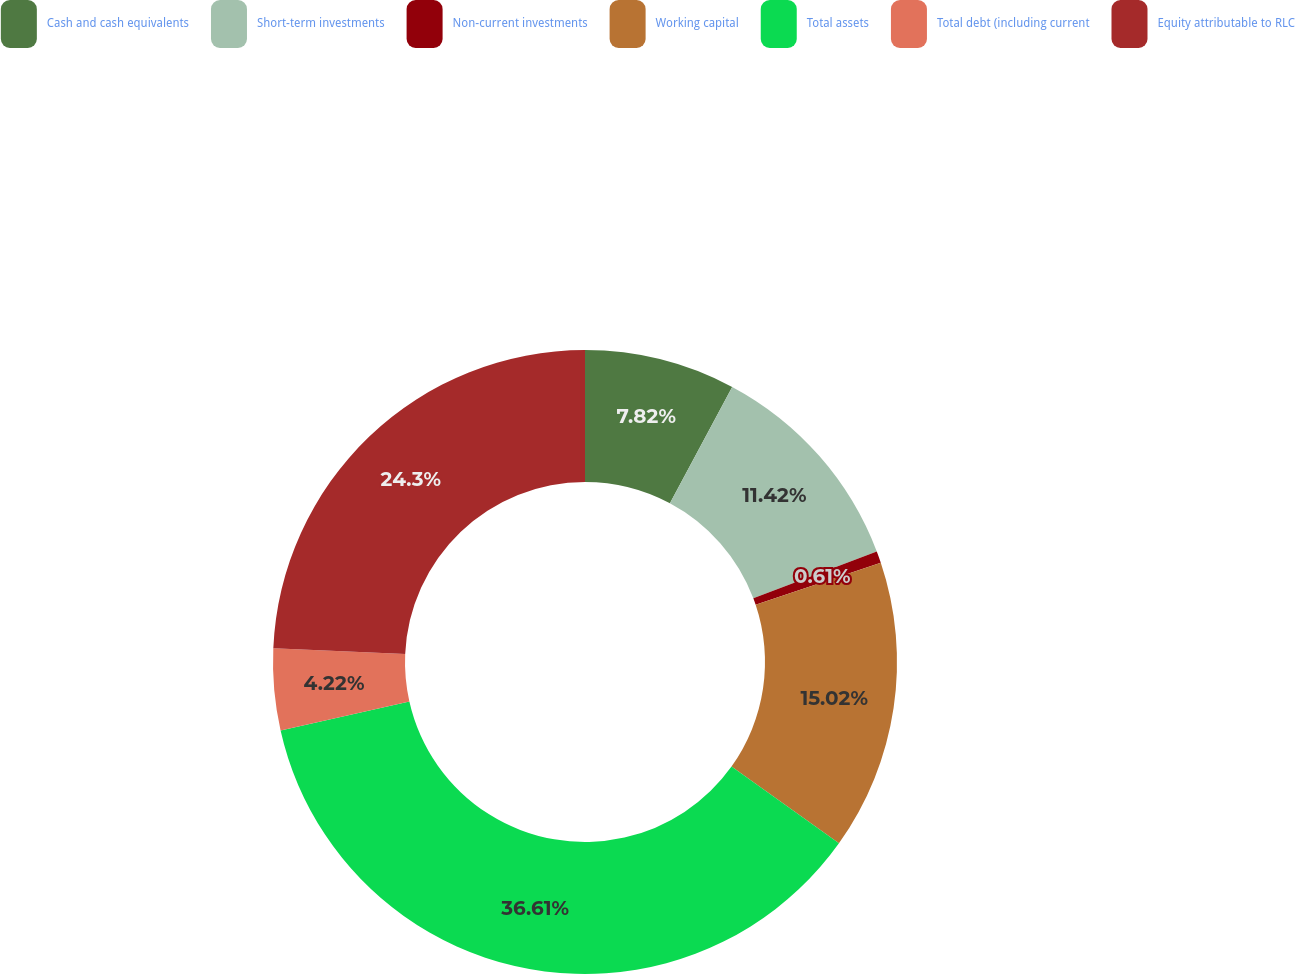Convert chart to OTSL. <chart><loc_0><loc_0><loc_500><loc_500><pie_chart><fcel>Cash and cash equivalents<fcel>Short-term investments<fcel>Non-current investments<fcel>Working capital<fcel>Total assets<fcel>Total debt (including current<fcel>Equity attributable to RLC<nl><fcel>7.82%<fcel>11.42%<fcel>0.61%<fcel>15.02%<fcel>36.62%<fcel>4.22%<fcel>24.3%<nl></chart> 